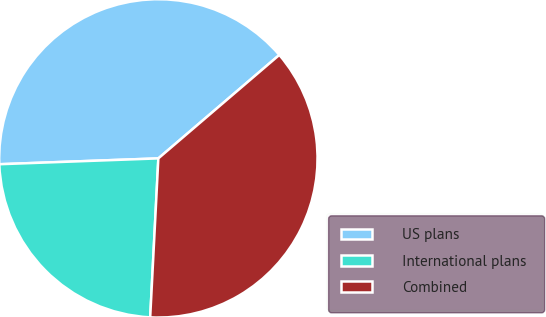<chart> <loc_0><loc_0><loc_500><loc_500><pie_chart><fcel>US plans<fcel>International plans<fcel>Combined<nl><fcel>39.33%<fcel>23.6%<fcel>37.08%<nl></chart> 